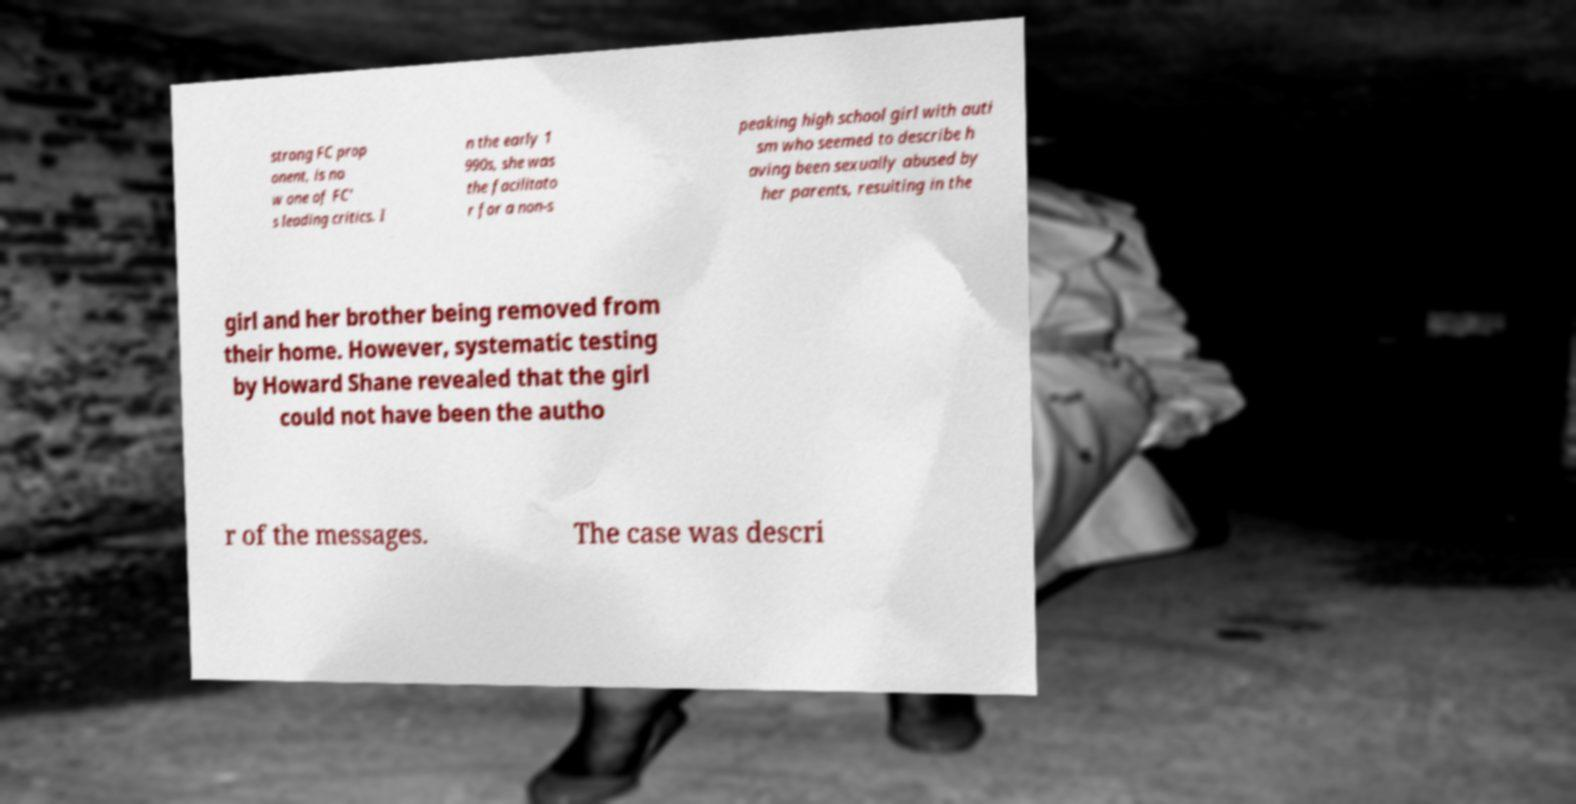What messages or text are displayed in this image? I need them in a readable, typed format. strong FC prop onent, is no w one of FC' s leading critics. I n the early 1 990s, she was the facilitato r for a non-s peaking high school girl with auti sm who seemed to describe h aving been sexually abused by her parents, resulting in the girl and her brother being removed from their home. However, systematic testing by Howard Shane revealed that the girl could not have been the autho r of the messages. The case was descri 